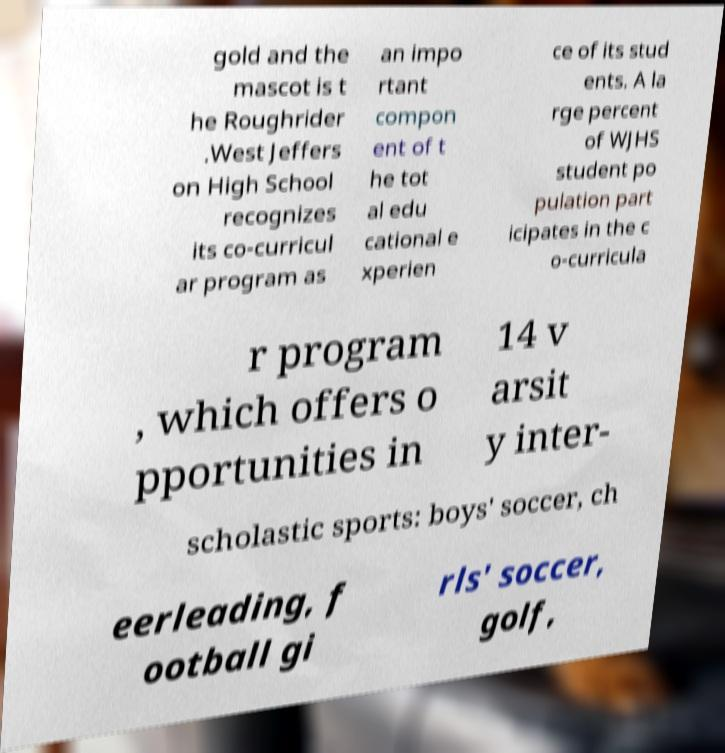Please read and relay the text visible in this image. What does it say? gold and the mascot is t he Roughrider .West Jeffers on High School recognizes its co-curricul ar program as an impo rtant compon ent of t he tot al edu cational e xperien ce of its stud ents. A la rge percent of WJHS student po pulation part icipates in the c o-curricula r program , which offers o pportunities in 14 v arsit y inter- scholastic sports: boys' soccer, ch eerleading, f ootball gi rls' soccer, golf, 